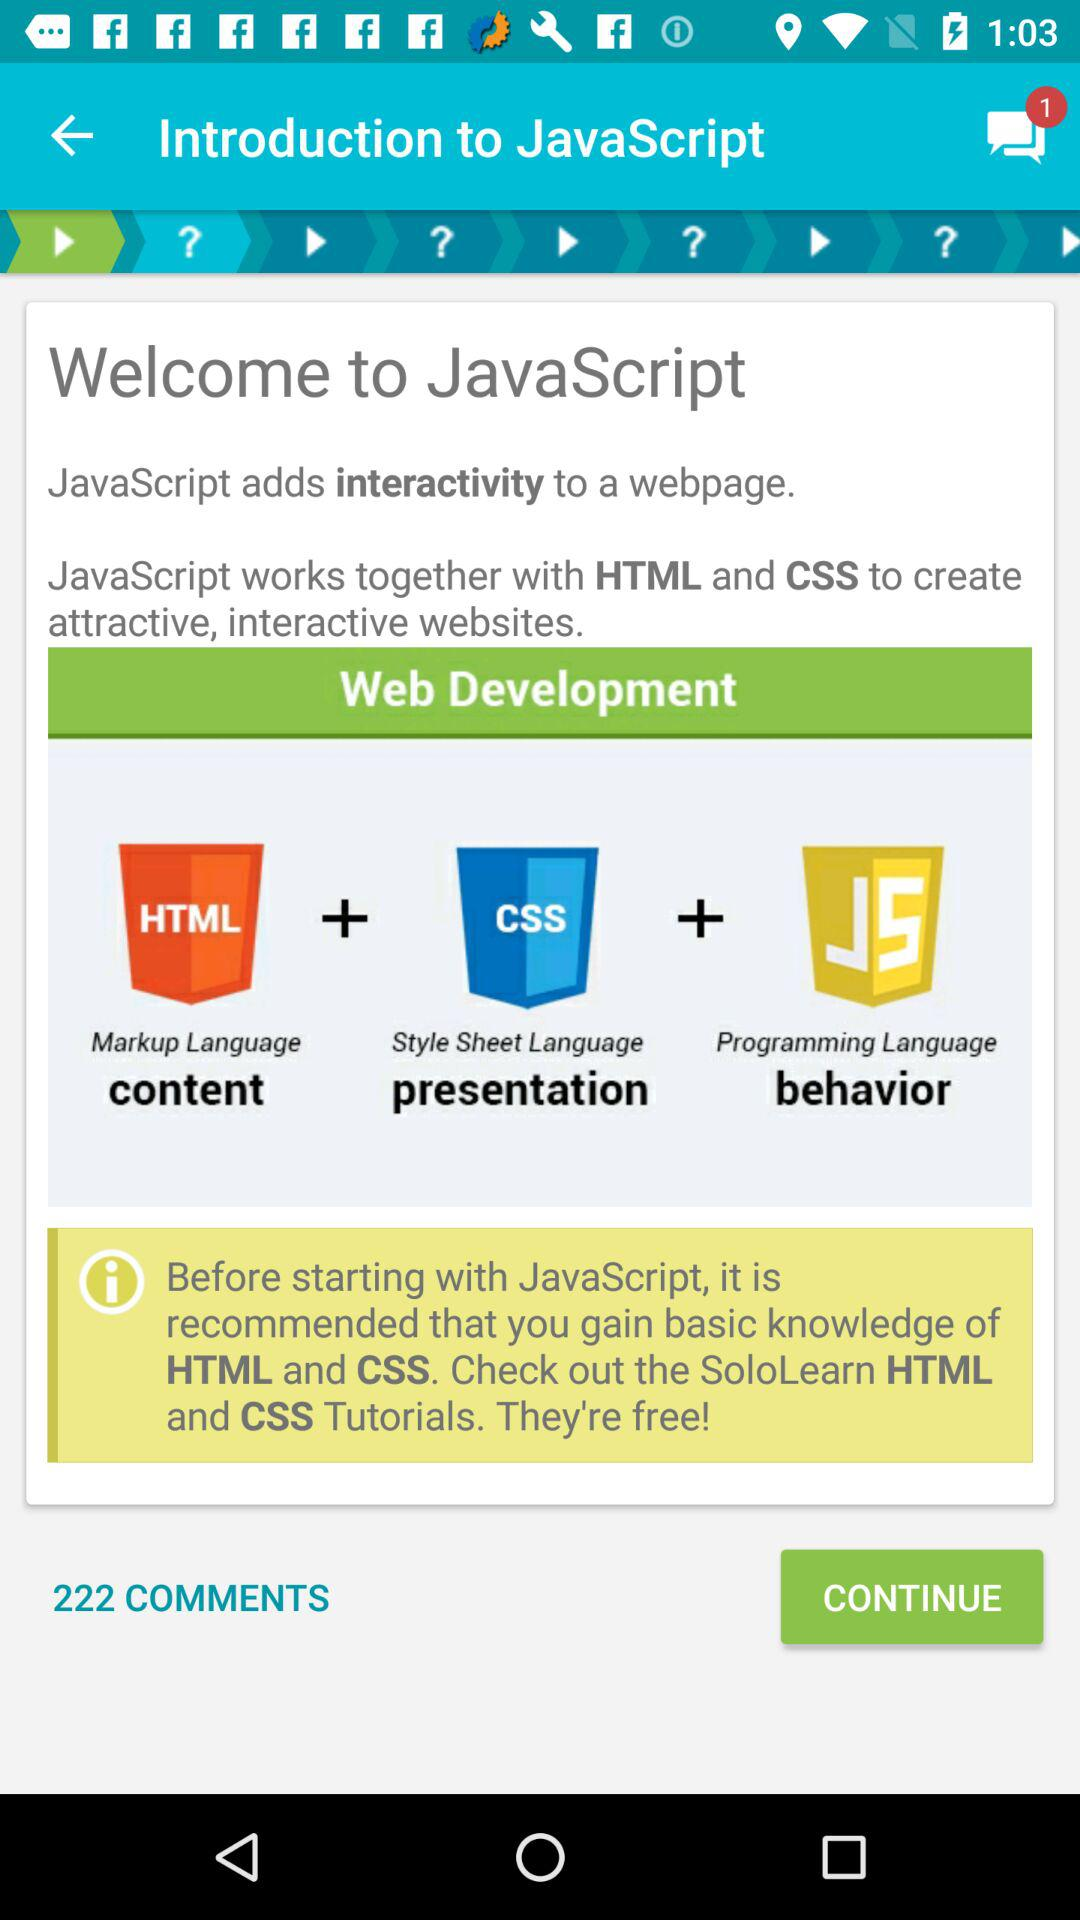How many comments in total are there? There are 222 comments. 